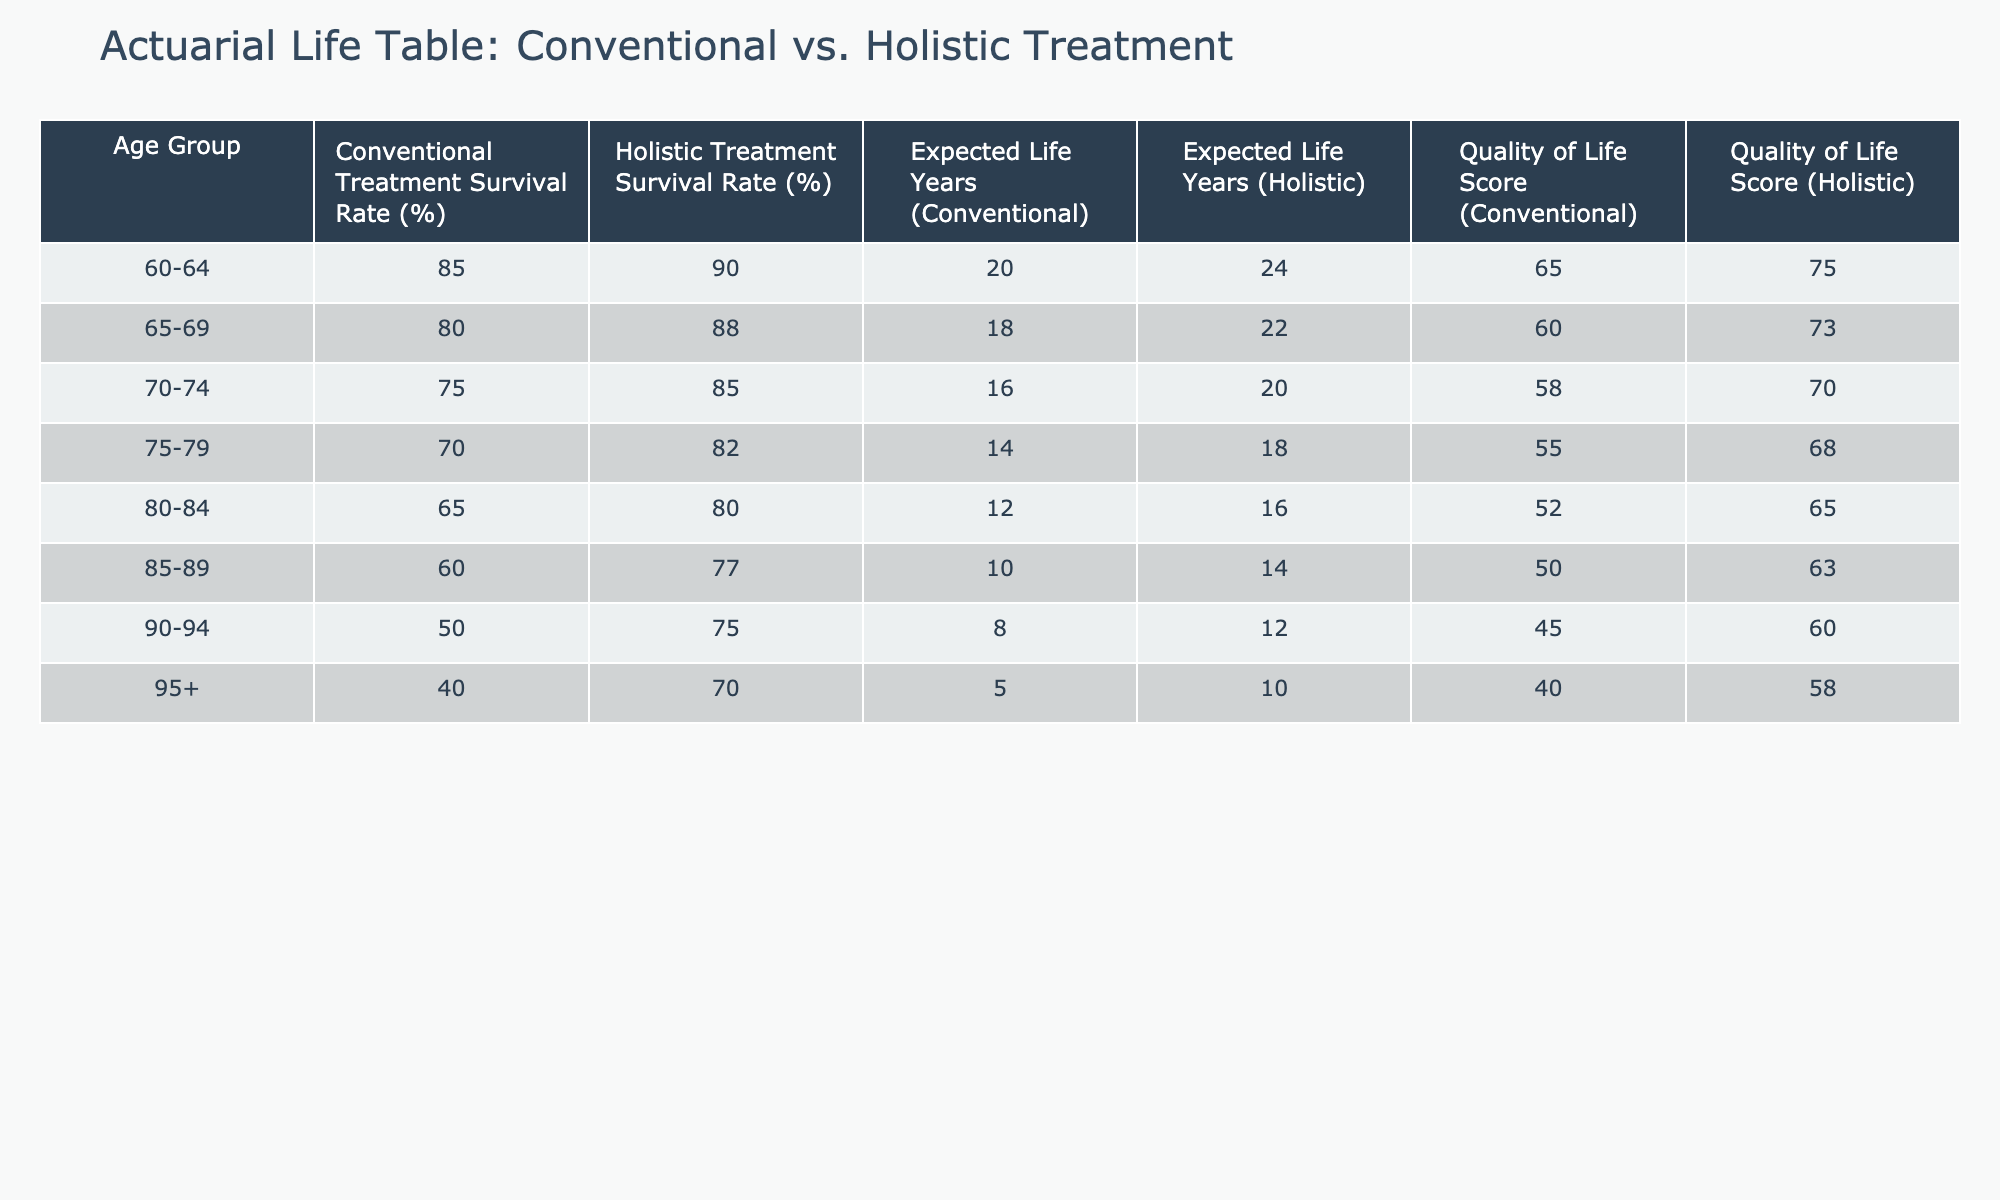What is the survival rate for patients aged 80-84 undergoing Conventional Treatment? The table shows that the survival rate for the age group 80-84 under Conventional Treatment is 65%.
Answer: 65% What is the expected life years for patients aged 75-79 receiving Holistic Treatment? According to the table, the expected life years for the 75-79 age group receiving Holistic Treatment is 18 years.
Answer: 18 Is the Quality of Life Score higher for Holistic Treatment than for Conventional Treatment in the age group 85-89? Yes, the Quality of Life Score for Holistic Treatment (63) is higher than that for Conventional Treatment (50) in the age group 85-89, indicating better quality of life.
Answer: Yes What is the difference in expected life years between Conventional and Holistic Treatment for the 70-74 age group? The expected life years for Conventional Treatment in the 70-74 age group is 16 and for Holistic Treatment is 20. The difference is 20 - 16 = 4 years.
Answer: 4 What is the average Quality of Life Score for Holistic Treatment across all age groups? To find the average, we sum the Quality of Life Scores for Holistic Treatment: 75 + 73 + 70 + 68 + 65 + 63 + 60 + 58 = 460. With 8 age groups, the average is 460 / 8 = 57.5.
Answer: 57.5 